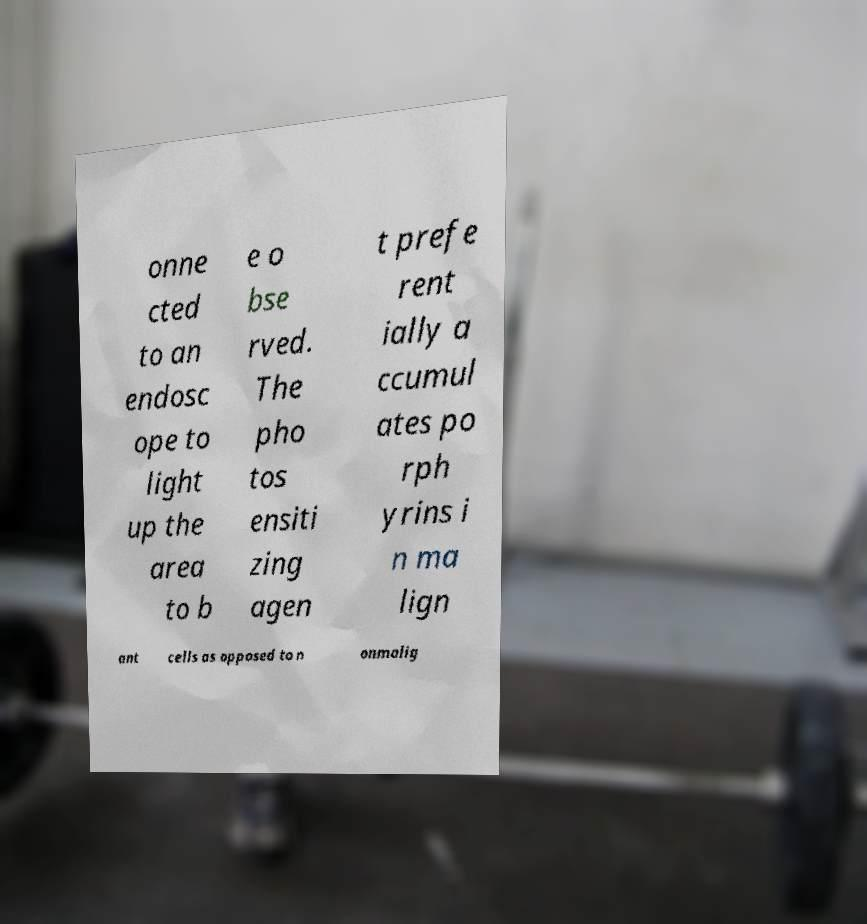Can you read and provide the text displayed in the image?This photo seems to have some interesting text. Can you extract and type it out for me? onne cted to an endosc ope to light up the area to b e o bse rved. The pho tos ensiti zing agen t prefe rent ially a ccumul ates po rph yrins i n ma lign ant cells as opposed to n onmalig 